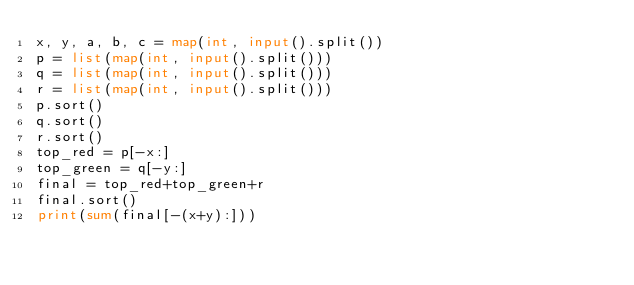<code> <loc_0><loc_0><loc_500><loc_500><_Python_>x, y, a, b, c = map(int, input().split())
p = list(map(int, input().split()))
q = list(map(int, input().split()))
r = list(map(int, input().split()))
p.sort()
q.sort()
r.sort()
top_red = p[-x:]
top_green = q[-y:]
final = top_red+top_green+r
final.sort()
print(sum(final[-(x+y):]))</code> 